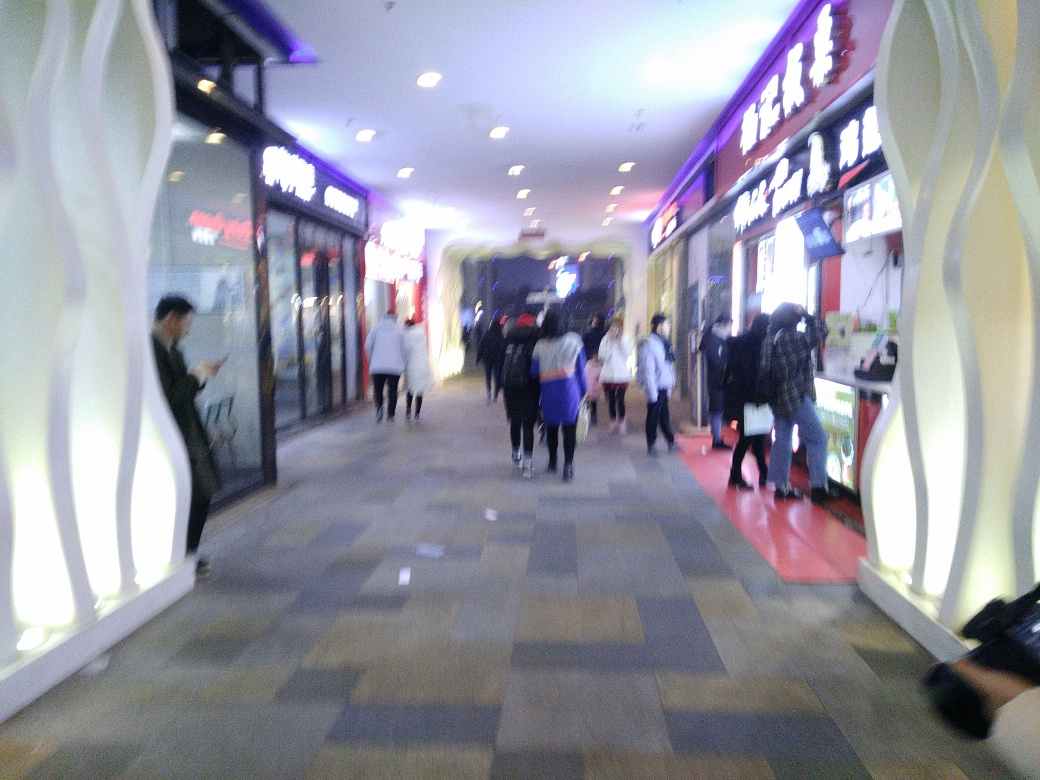Does the image have good viewing experience? The image does not provide a good viewing experience as it is blurry and lacks clarity, making it difficult to discern details that might be of interest to the viewer. 